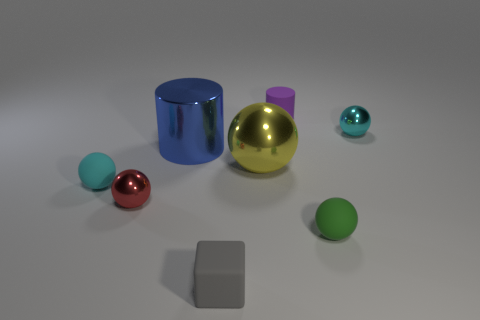What is the color of the other rubber ball that is the same size as the green matte sphere? The rubber ball that matches the size of the green matte sphere is cyan, which is a shade of light bluish-green. 